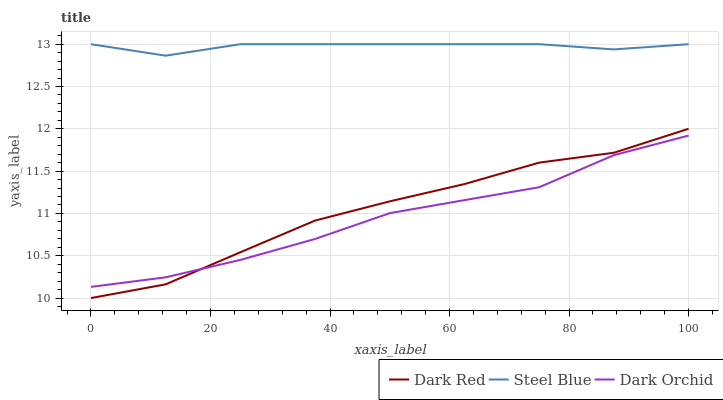Does Dark Orchid have the minimum area under the curve?
Answer yes or no. Yes. Does Steel Blue have the maximum area under the curve?
Answer yes or no. Yes. Does Steel Blue have the minimum area under the curve?
Answer yes or no. No. Does Dark Orchid have the maximum area under the curve?
Answer yes or no. No. Is Steel Blue the smoothest?
Answer yes or no. Yes. Is Dark Red the roughest?
Answer yes or no. Yes. Is Dark Orchid the smoothest?
Answer yes or no. No. Is Dark Orchid the roughest?
Answer yes or no. No. Does Dark Red have the lowest value?
Answer yes or no. Yes. Does Dark Orchid have the lowest value?
Answer yes or no. No. Does Steel Blue have the highest value?
Answer yes or no. Yes. Does Dark Orchid have the highest value?
Answer yes or no. No. Is Dark Red less than Steel Blue?
Answer yes or no. Yes. Is Steel Blue greater than Dark Orchid?
Answer yes or no. Yes. Does Dark Orchid intersect Dark Red?
Answer yes or no. Yes. Is Dark Orchid less than Dark Red?
Answer yes or no. No. Is Dark Orchid greater than Dark Red?
Answer yes or no. No. Does Dark Red intersect Steel Blue?
Answer yes or no. No. 